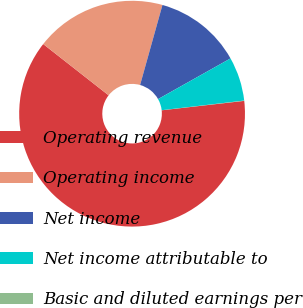Convert chart. <chart><loc_0><loc_0><loc_500><loc_500><pie_chart><fcel>Operating revenue<fcel>Operating income<fcel>Net income<fcel>Net income attributable to<fcel>Basic and diluted earnings per<nl><fcel>62.39%<fcel>18.76%<fcel>12.52%<fcel>6.29%<fcel>0.04%<nl></chart> 